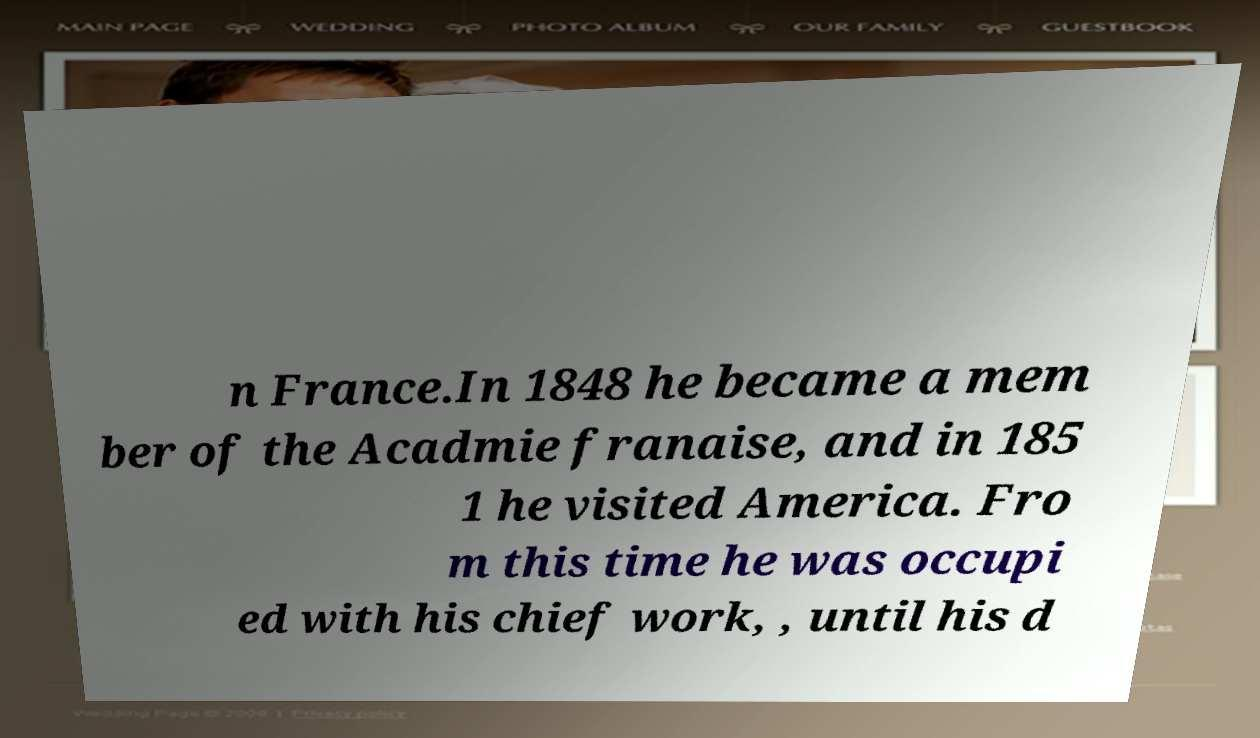Please read and relay the text visible in this image. What does it say? n France.In 1848 he became a mem ber of the Acadmie franaise, and in 185 1 he visited America. Fro m this time he was occupi ed with his chief work, , until his d 